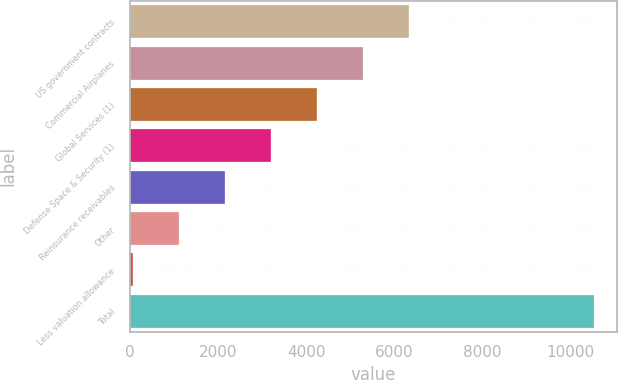<chart> <loc_0><loc_0><loc_500><loc_500><bar_chart><fcel>US government contracts<fcel>Commercial Airplanes<fcel>Global Services (1)<fcel>Defense Space & Security (1)<fcel>Reinsurance receivables<fcel>Other<fcel>Less valuation allowance<fcel>Total<nl><fcel>6334.4<fcel>5289<fcel>4243.6<fcel>3198.2<fcel>2152.8<fcel>1107.4<fcel>62<fcel>10516<nl></chart> 